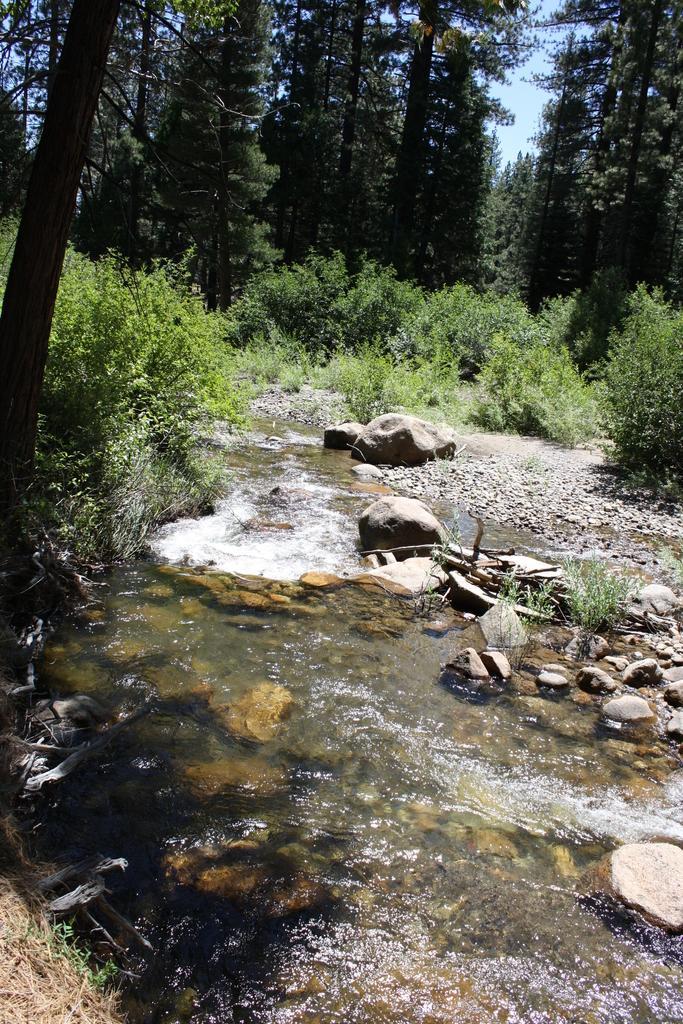What type of natural elements can be seen in the image? There are stones, water, plants, and trees visible in the image. What is the color of the plants in the image? The plants in the image are green in color. What is the color of the trees in the image? The trees in the image are green in color. What is the color of the sky in the image? The sky is white in color. Can you see a monkey eating a cracker in the image? No, there is no monkey or cracker present in the image. Are there any nails visible in the image? No, there are no nails visible in the image. 